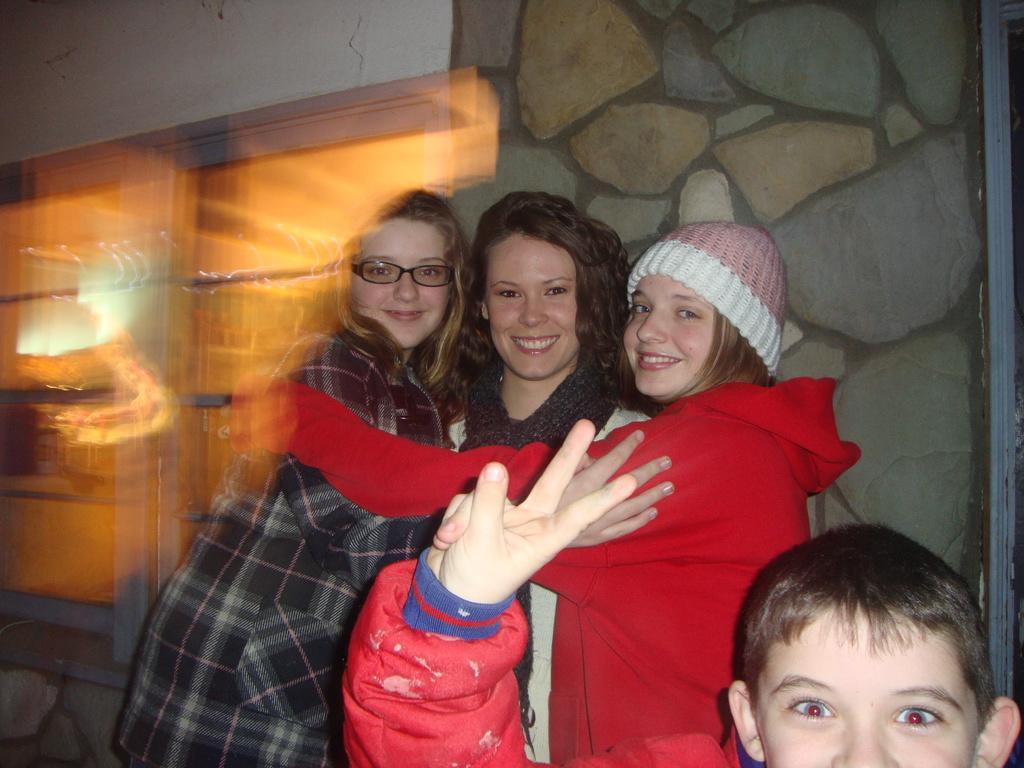Please provide a concise description of this image. In the center of the image there are persons standing. At the bottom there is a boy. In the background of the image there is wall. 